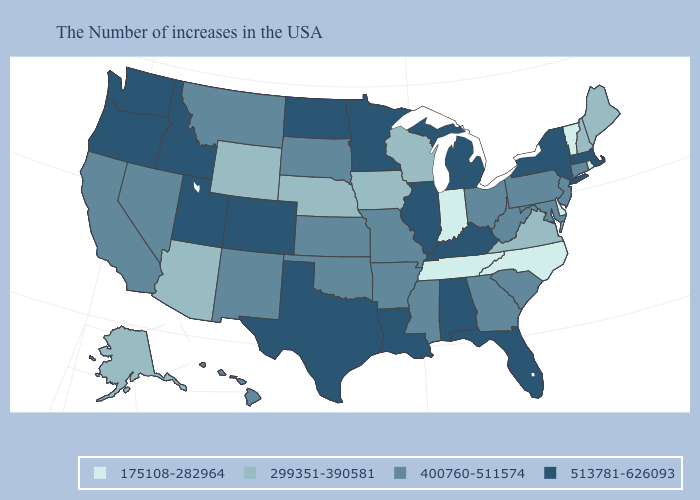Does Michigan have the highest value in the MidWest?
Be succinct. Yes. Does Delaware have the lowest value in the USA?
Short answer required. Yes. Name the states that have a value in the range 299351-390581?
Be succinct. Maine, New Hampshire, Virginia, Wisconsin, Iowa, Nebraska, Wyoming, Arizona, Alaska. What is the highest value in the USA?
Short answer required. 513781-626093. What is the value of Iowa?
Be succinct. 299351-390581. Name the states that have a value in the range 400760-511574?
Concise answer only. Connecticut, New Jersey, Maryland, Pennsylvania, South Carolina, West Virginia, Ohio, Georgia, Mississippi, Missouri, Arkansas, Kansas, Oklahoma, South Dakota, New Mexico, Montana, Nevada, California, Hawaii. What is the highest value in the USA?
Concise answer only. 513781-626093. Does Nebraska have the lowest value in the USA?
Be succinct. No. What is the value of Ohio?
Short answer required. 400760-511574. Name the states that have a value in the range 175108-282964?
Keep it brief. Rhode Island, Vermont, Delaware, North Carolina, Indiana, Tennessee. What is the highest value in states that border Arizona?
Give a very brief answer. 513781-626093. What is the highest value in states that border Alabama?
Short answer required. 513781-626093. Does Colorado have a higher value than Michigan?
Give a very brief answer. No. Which states have the lowest value in the USA?
Answer briefly. Rhode Island, Vermont, Delaware, North Carolina, Indiana, Tennessee. Name the states that have a value in the range 175108-282964?
Quick response, please. Rhode Island, Vermont, Delaware, North Carolina, Indiana, Tennessee. 